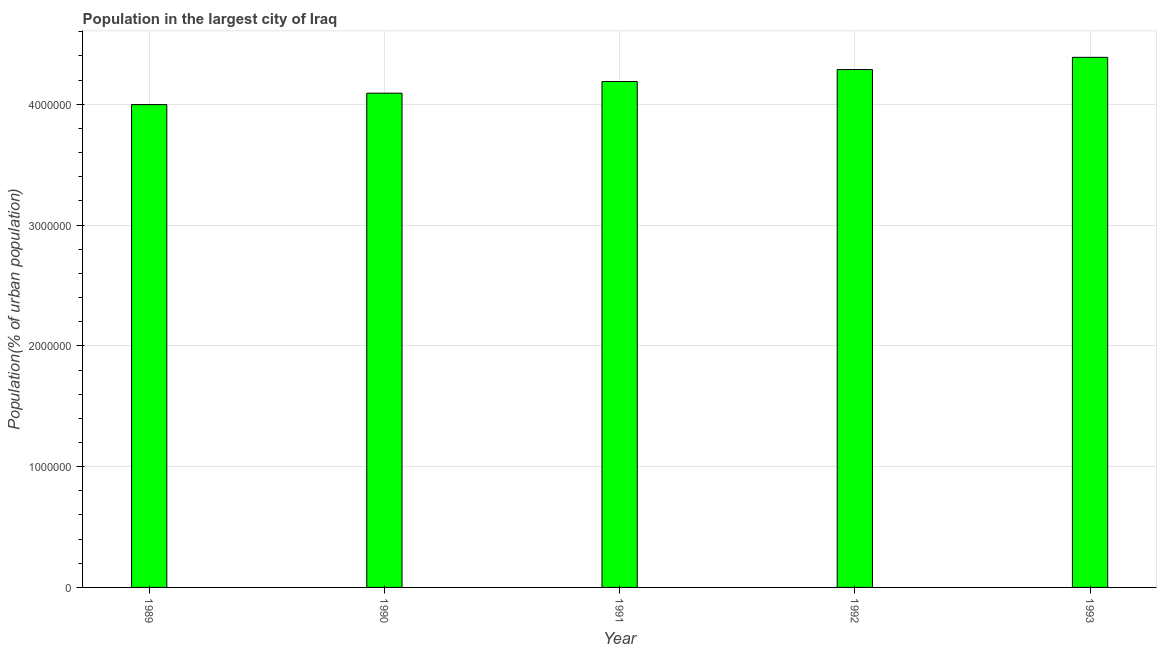What is the title of the graph?
Offer a terse response. Population in the largest city of Iraq. What is the label or title of the Y-axis?
Your answer should be compact. Population(% of urban population). What is the population in largest city in 1993?
Provide a succinct answer. 4.39e+06. Across all years, what is the maximum population in largest city?
Make the answer very short. 4.39e+06. Across all years, what is the minimum population in largest city?
Your answer should be very brief. 4.00e+06. In which year was the population in largest city maximum?
Offer a terse response. 1993. What is the sum of the population in largest city?
Give a very brief answer. 2.10e+07. What is the difference between the population in largest city in 1989 and 1993?
Ensure brevity in your answer.  -3.91e+05. What is the average population in largest city per year?
Give a very brief answer. 4.19e+06. What is the median population in largest city?
Give a very brief answer. 4.19e+06. In how many years, is the population in largest city greater than 800000 %?
Your response must be concise. 5. Is the population in largest city in 1989 less than that in 1992?
Ensure brevity in your answer.  Yes. What is the difference between the highest and the second highest population in largest city?
Provide a short and direct response. 1.01e+05. Is the sum of the population in largest city in 1992 and 1993 greater than the maximum population in largest city across all years?
Keep it short and to the point. Yes. What is the difference between the highest and the lowest population in largest city?
Provide a short and direct response. 3.91e+05. Are all the bars in the graph horizontal?
Offer a very short reply. No. How many years are there in the graph?
Your response must be concise. 5. What is the difference between two consecutive major ticks on the Y-axis?
Provide a short and direct response. 1.00e+06. What is the Population(% of urban population) of 1989?
Your answer should be very brief. 4.00e+06. What is the Population(% of urban population) of 1990?
Make the answer very short. 4.09e+06. What is the Population(% of urban population) in 1991?
Offer a terse response. 4.19e+06. What is the Population(% of urban population) in 1992?
Offer a very short reply. 4.29e+06. What is the Population(% of urban population) in 1993?
Give a very brief answer. 4.39e+06. What is the difference between the Population(% of urban population) in 1989 and 1990?
Provide a short and direct response. -9.44e+04. What is the difference between the Population(% of urban population) in 1989 and 1991?
Your response must be concise. -1.91e+05. What is the difference between the Population(% of urban population) in 1989 and 1992?
Offer a terse response. -2.90e+05. What is the difference between the Population(% of urban population) in 1989 and 1993?
Offer a very short reply. -3.91e+05. What is the difference between the Population(% of urban population) in 1990 and 1991?
Your response must be concise. -9.67e+04. What is the difference between the Population(% of urban population) in 1990 and 1992?
Keep it short and to the point. -1.96e+05. What is the difference between the Population(% of urban population) in 1990 and 1993?
Provide a succinct answer. -2.97e+05. What is the difference between the Population(% of urban population) in 1991 and 1992?
Your response must be concise. -9.91e+04. What is the difference between the Population(% of urban population) in 1991 and 1993?
Give a very brief answer. -2.00e+05. What is the difference between the Population(% of urban population) in 1992 and 1993?
Make the answer very short. -1.01e+05. What is the ratio of the Population(% of urban population) in 1989 to that in 1990?
Your answer should be compact. 0.98. What is the ratio of the Population(% of urban population) in 1989 to that in 1991?
Your answer should be very brief. 0.95. What is the ratio of the Population(% of urban population) in 1989 to that in 1992?
Your answer should be very brief. 0.93. What is the ratio of the Population(% of urban population) in 1989 to that in 1993?
Make the answer very short. 0.91. What is the ratio of the Population(% of urban population) in 1990 to that in 1992?
Offer a terse response. 0.95. What is the ratio of the Population(% of urban population) in 1990 to that in 1993?
Make the answer very short. 0.93. What is the ratio of the Population(% of urban population) in 1991 to that in 1992?
Provide a succinct answer. 0.98. What is the ratio of the Population(% of urban population) in 1991 to that in 1993?
Keep it short and to the point. 0.95. 